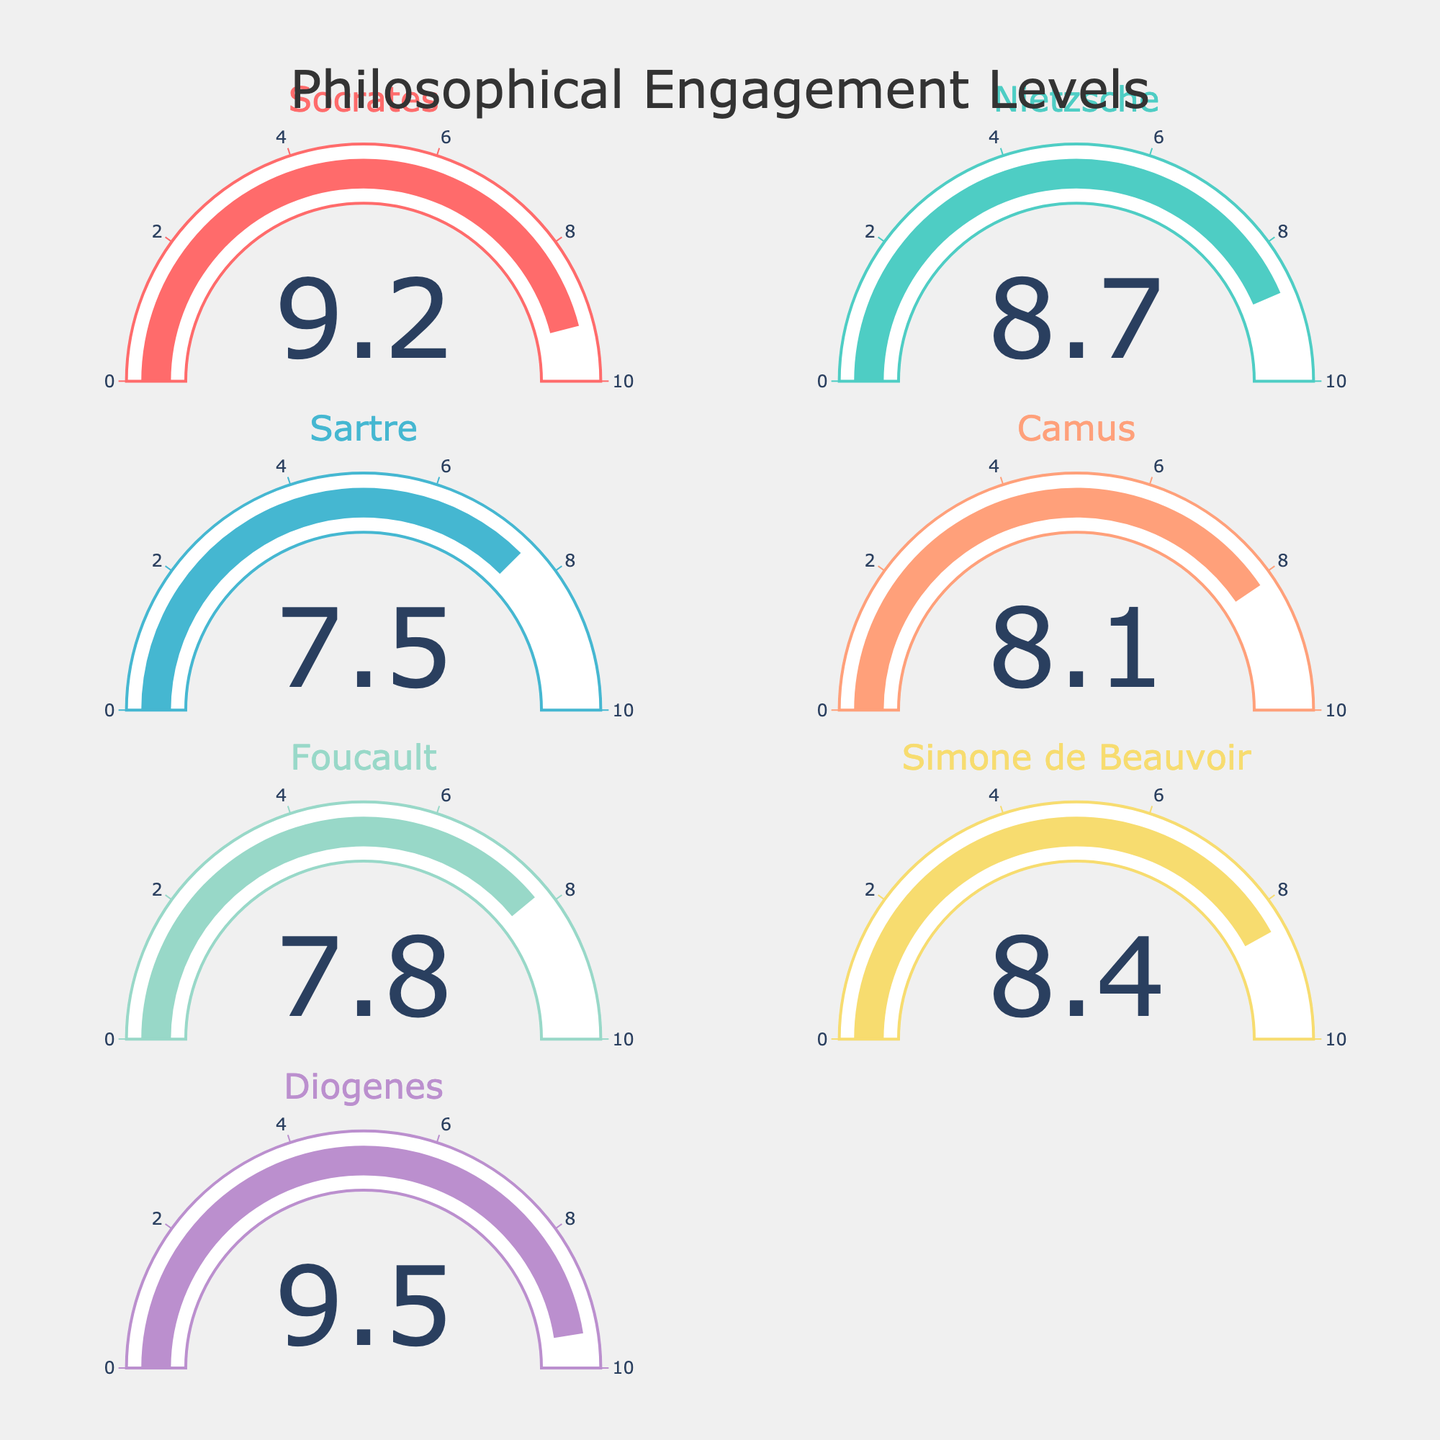What is the engagement level of Sartre? Look at the gauge labeled "Sartre" to find the engagement level. It shows 7.5.
Answer: 7.5 Who has the highest level of engagement? Compare the engagement levels displayed on each gauge. Diogenes has the highest level at 9.5.
Answer: Diogenes How many philosophers have an engagement level above 8.0? Identify and count the gauges with levels above 8.0. The philosophers are Socrates (9.2), Nietzsche (8.7), Camus (8.1), and Simone de Beauvoir (8.4). There are 4 philosophers.
Answer: 4 What is the average engagement level of the philosophers? Add the engagement levels: 9.2 + 8.7 + 7.5 + 8.1 + 7.8 + 8.4 + 9.5 = 59.2. Divide by the number of philosophers, which is 7. So, the average is 59.2 / 7 ≈ 8.46.
Answer: 8.46 Who has the lowest engagement level? Compare the engagement levels displayed on each gauge. Sartre has the lowest level at 7.5.
Answer: Sartre What is the total engagement level of Socrates and Diogenes combined? Add the engagement levels of Socrates and Diogenes: 9.2 + 9.5 = 18.7.
Answer: 18.7 Which philosopher's engagement level is closest to the average engagement level? First, calculate the average engagement level: 59.2 / 7 ≈ 8.46. Check each philosopher's deviation from 8.46. The closest is Nietzsche with 8.7, a difference of 0.24.
Answer: Nietzsche What is the range of engagement levels among the philosophers? Subtract the lowest engagement level from the highest: 9.5 (Diogenes) - 7.5 (Sartre) = 2.
Answer: 2 What is the difference in engagement level between Simone de Beauvoir and Foucault? Subtract Foucault's level from Simone de Beauvoir's level: 8.4 - 7.8 = 0.6.
Answer: 0.6 What is the median engagement level of the philosophers? List the levels in order: 7.5, 7.8, 8.1, 8.4, 8.7, 9.2, 9.5. The middle value, or median, is the fourth value: 8.4 (Simone de Beauvoir).
Answer: 8.4 